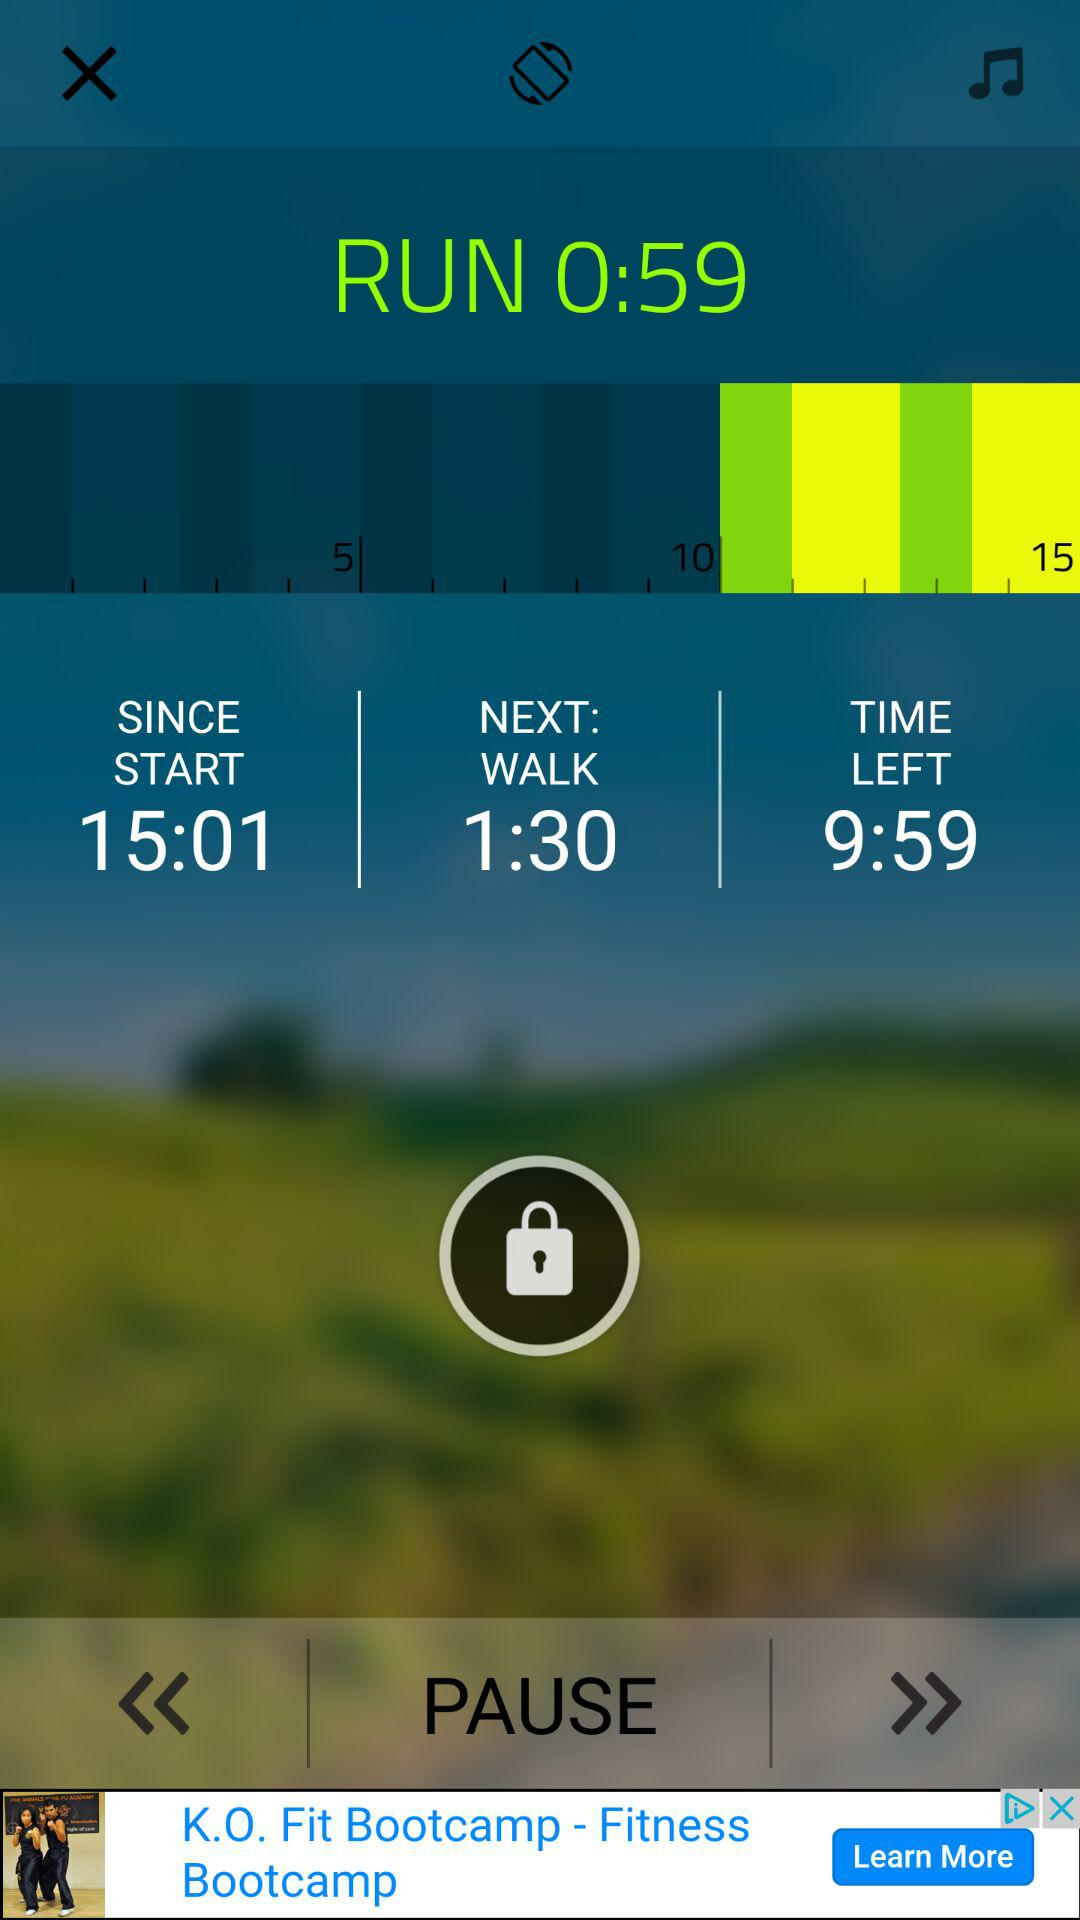At what time did the run start? The run started at 15:01. 